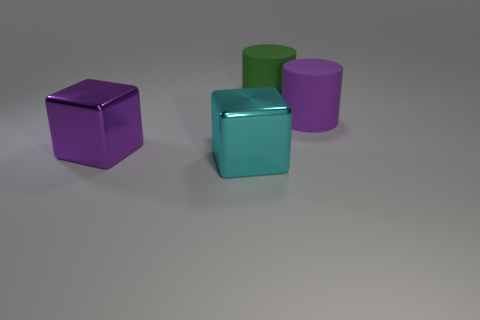How would the scene be different if it were outdoors? If the scene were set outdoors, natural elements like lighting, shadows, and perhaps a background landscape would change the visual dynamics. The play of sunlight and shadows could enhance the textures and colors of the objects, potentially casting interesting patterns on their surfaces. The backdrop, whether it's a blue sky, greenery, or an urban setting, would add context and perhaps suggest a narrative or function for these objects. Could these objects be part of a larger installation or artwork? Absolutely! These objects could be components of a modern art installation, playing with concepts of color, form, and scale. Alternatively, they might be interactive pieces in a sensory exhibit, inviting observers to engage with them—feeling their textures, observing the effects of light on their surfaces, or even rearranging them into new configurations. 